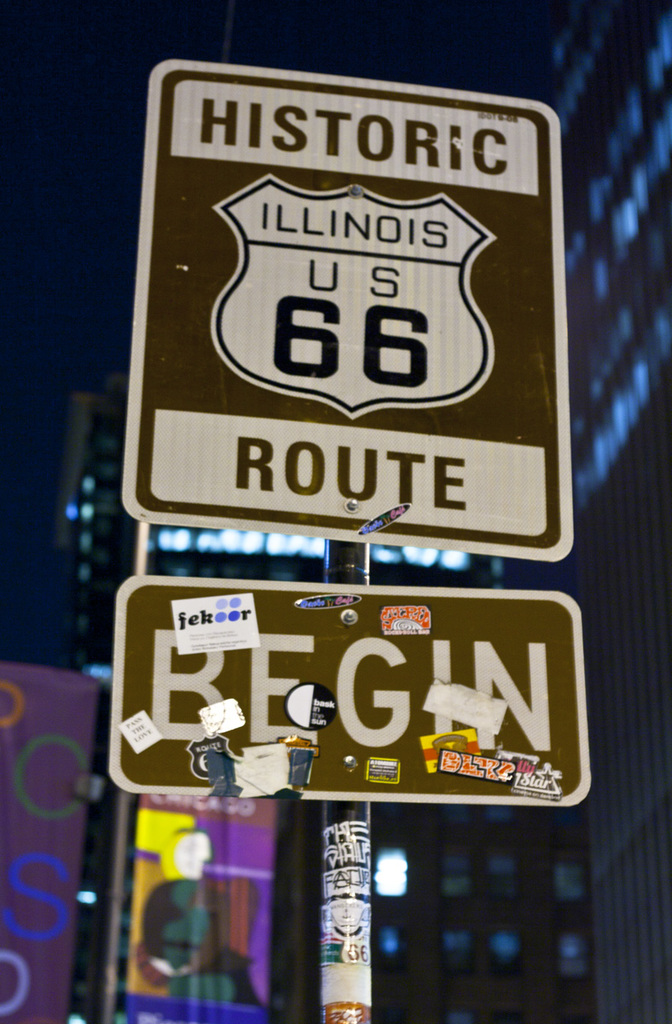What do you think is going on in this snapshot? The image shows the iconic starting point of Historic Route 66 in Illinois, marked by a distinctive sign. This sign not only signals the beginning of a major American highway but also stands as a symbol of adventure and freedom, a starting point for countless road trips across the United States. Adorned with an array of stickers and tags, the sign also reflects the personal marks left by travelers who have embarked on the journey from this spot, underscoring Route 66's role in American cultural and historical identity. The nighttime setting, illuminated by city lights, adds to the allure, inviting onlookers to contemplate the explorations that have commenced here. 